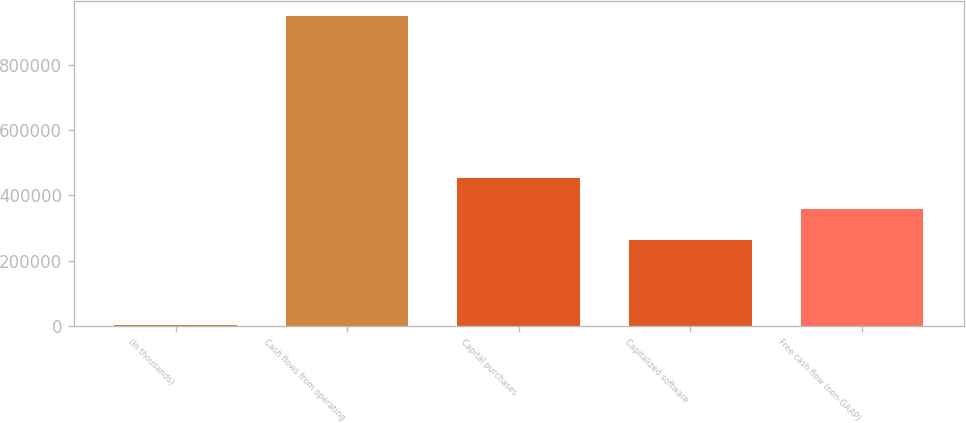Convert chart. <chart><loc_0><loc_0><loc_500><loc_500><bar_chart><fcel>(In thousands)<fcel>Cash flows from operating<fcel>Capital purchases<fcel>Capitalized software<fcel>Free cash flow (non-GAAP)<nl><fcel>2015<fcel>947526<fcel>453758<fcel>264656<fcel>359207<nl></chart> 